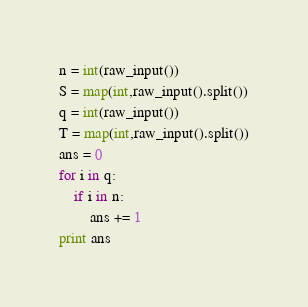<code> <loc_0><loc_0><loc_500><loc_500><_Python_>n = int(raw_input())
S = map(int,raw_input().split())
q = int(raw_input())
T = map(int,raw_input().split())
ans = 0
for i in q:
	if i in n:
		ans += 1
print ans</code> 